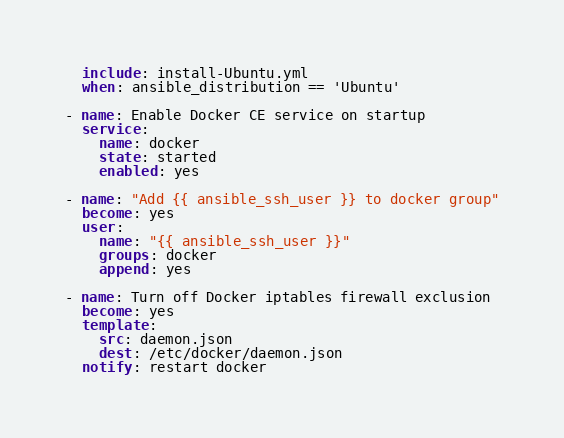Convert code to text. <code><loc_0><loc_0><loc_500><loc_500><_YAML_>  include: install-Ubuntu.yml
  when: ansible_distribution == 'Ubuntu'

- name: Enable Docker CE service on startup
  service:
    name: docker
    state: started
    enabled: yes

- name: "Add {{ ansible_ssh_user }} to docker group"
  become: yes
  user:
    name: "{{ ansible_ssh_user }}"
    groups: docker
    append: yes

- name: Turn off Docker iptables firewall exclusion
  become: yes
  template:
    src: daemon.json
    dest: /etc/docker/daemon.json
  notify: restart docker
</code> 